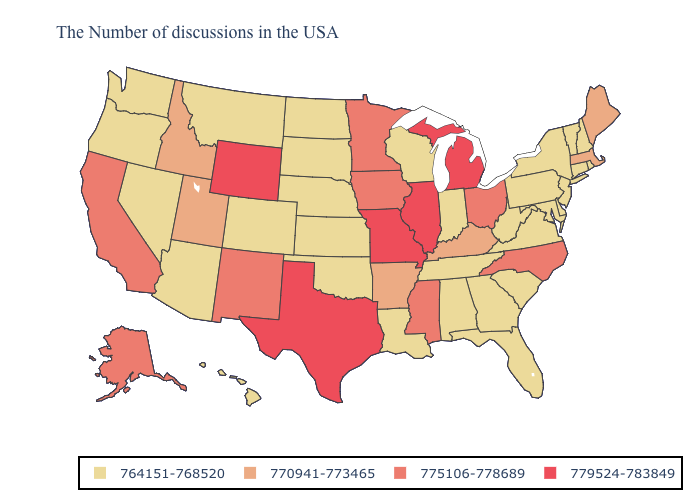Does Texas have the highest value in the South?
Keep it brief. Yes. Name the states that have a value in the range 770941-773465?
Write a very short answer. Maine, Massachusetts, Kentucky, Arkansas, Utah, Idaho. What is the lowest value in the South?
Keep it brief. 764151-768520. Does Wisconsin have the lowest value in the MidWest?
Short answer required. Yes. What is the value of Mississippi?
Keep it brief. 775106-778689. Is the legend a continuous bar?
Quick response, please. No. Name the states that have a value in the range 764151-768520?
Short answer required. Rhode Island, New Hampshire, Vermont, Connecticut, New York, New Jersey, Delaware, Maryland, Pennsylvania, Virginia, South Carolina, West Virginia, Florida, Georgia, Indiana, Alabama, Tennessee, Wisconsin, Louisiana, Kansas, Nebraska, Oklahoma, South Dakota, North Dakota, Colorado, Montana, Arizona, Nevada, Washington, Oregon, Hawaii. What is the value of Louisiana?
Give a very brief answer. 764151-768520. Name the states that have a value in the range 775106-778689?
Quick response, please. North Carolina, Ohio, Mississippi, Minnesota, Iowa, New Mexico, California, Alaska. What is the highest value in the USA?
Keep it brief. 779524-783849. How many symbols are there in the legend?
Short answer required. 4. Name the states that have a value in the range 770941-773465?
Answer briefly. Maine, Massachusetts, Kentucky, Arkansas, Utah, Idaho. What is the lowest value in states that border Louisiana?
Keep it brief. 770941-773465. Does Minnesota have the lowest value in the USA?
Give a very brief answer. No. What is the value of New Hampshire?
Write a very short answer. 764151-768520. 